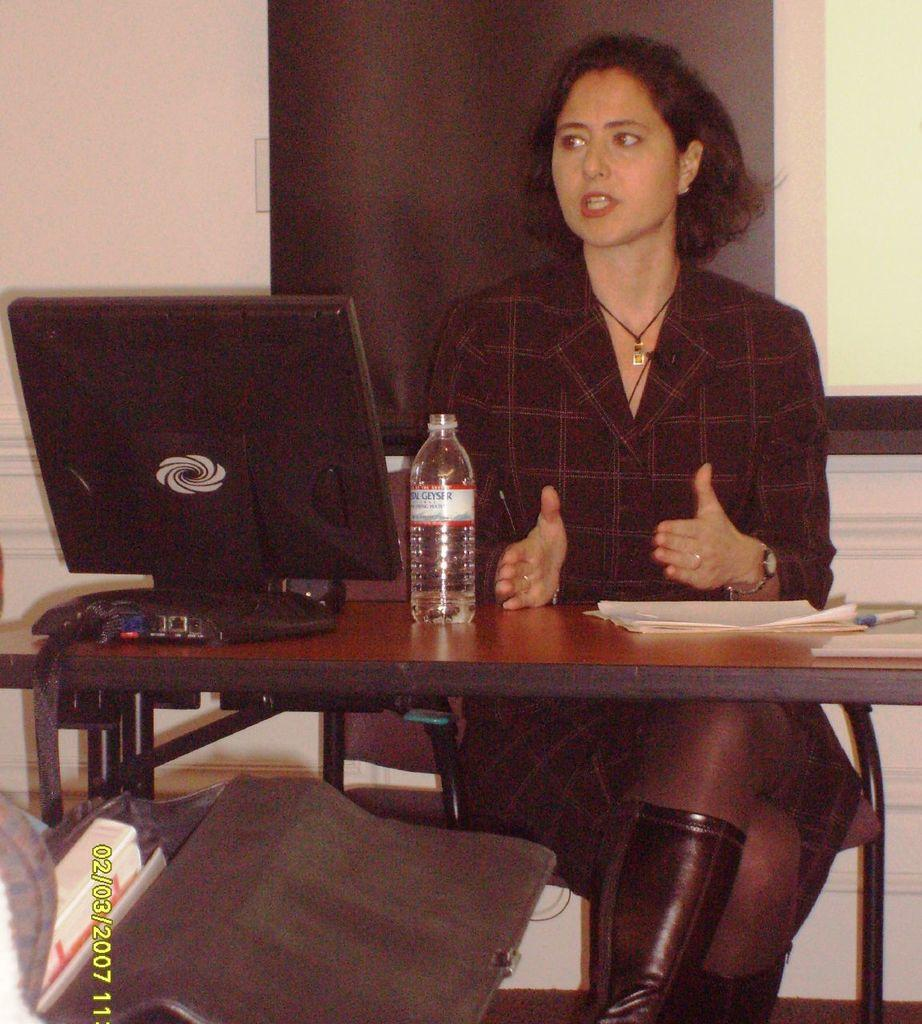Who is the main subject in the image? There is a lady in the image. What is the lady doing in the image? The lady is sitting on a table. What other objects are present on the table? There is a water bottle and a monitor on top of the water bottle. What type of marble is visible on the table in the image? There is no marble present in the image; the table contains a water bottle and a monitor. 